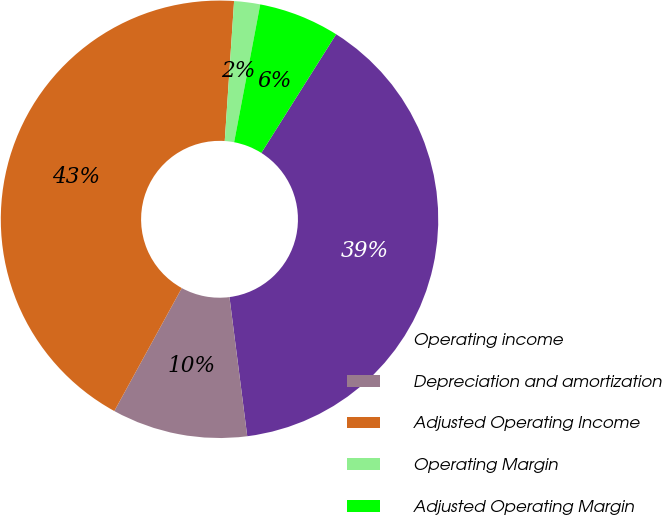Convert chart. <chart><loc_0><loc_0><loc_500><loc_500><pie_chart><fcel>Operating income<fcel>Depreciation and amortization<fcel>Adjusted Operating Income<fcel>Operating Margin<fcel>Adjusted Operating Margin<nl><fcel>39.03%<fcel>10.01%<fcel>43.08%<fcel>1.92%<fcel>5.97%<nl></chart> 